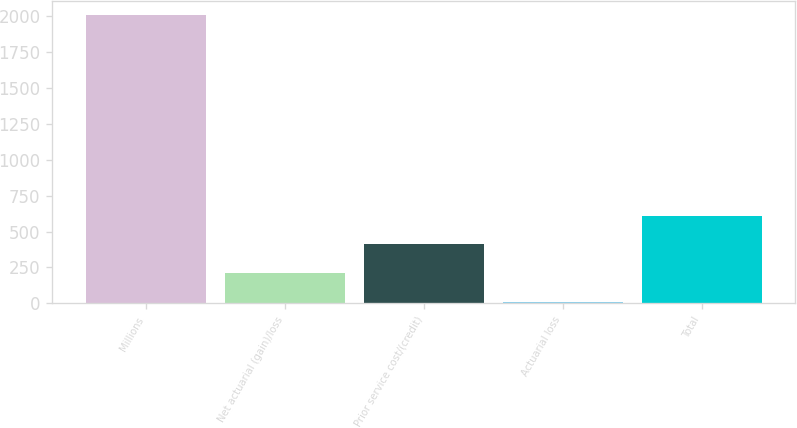Convert chart. <chart><loc_0><loc_0><loc_500><loc_500><bar_chart><fcel>Millions<fcel>Net actuarial (gain)/loss<fcel>Prior service cost/(credit)<fcel>Actuarial loss<fcel>Total<nl><fcel>2009<fcel>211.7<fcel>411.4<fcel>12<fcel>611.1<nl></chart> 